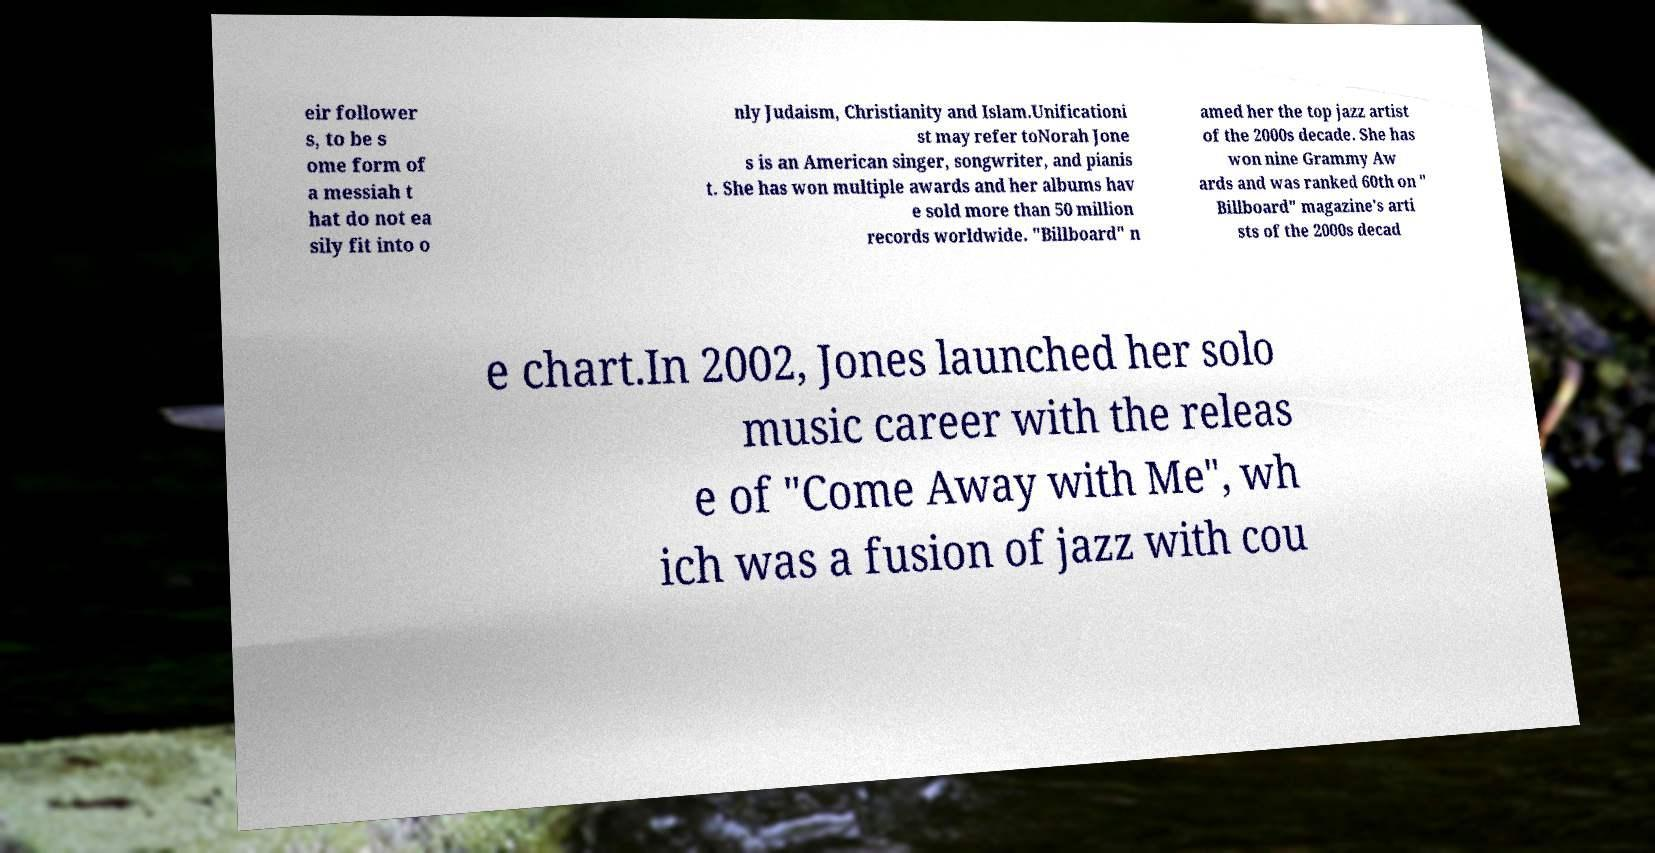What messages or text are displayed in this image? I need them in a readable, typed format. eir follower s, to be s ome form of a messiah t hat do not ea sily fit into o nly Judaism, Christianity and Islam.Unificationi st may refer toNorah Jone s is an American singer, songwriter, and pianis t. She has won multiple awards and her albums hav e sold more than 50 million records worldwide. "Billboard" n amed her the top jazz artist of the 2000s decade. She has won nine Grammy Aw ards and was ranked 60th on " Billboard" magazine's arti sts of the 2000s decad e chart.In 2002, Jones launched her solo music career with the releas e of "Come Away with Me", wh ich was a fusion of jazz with cou 